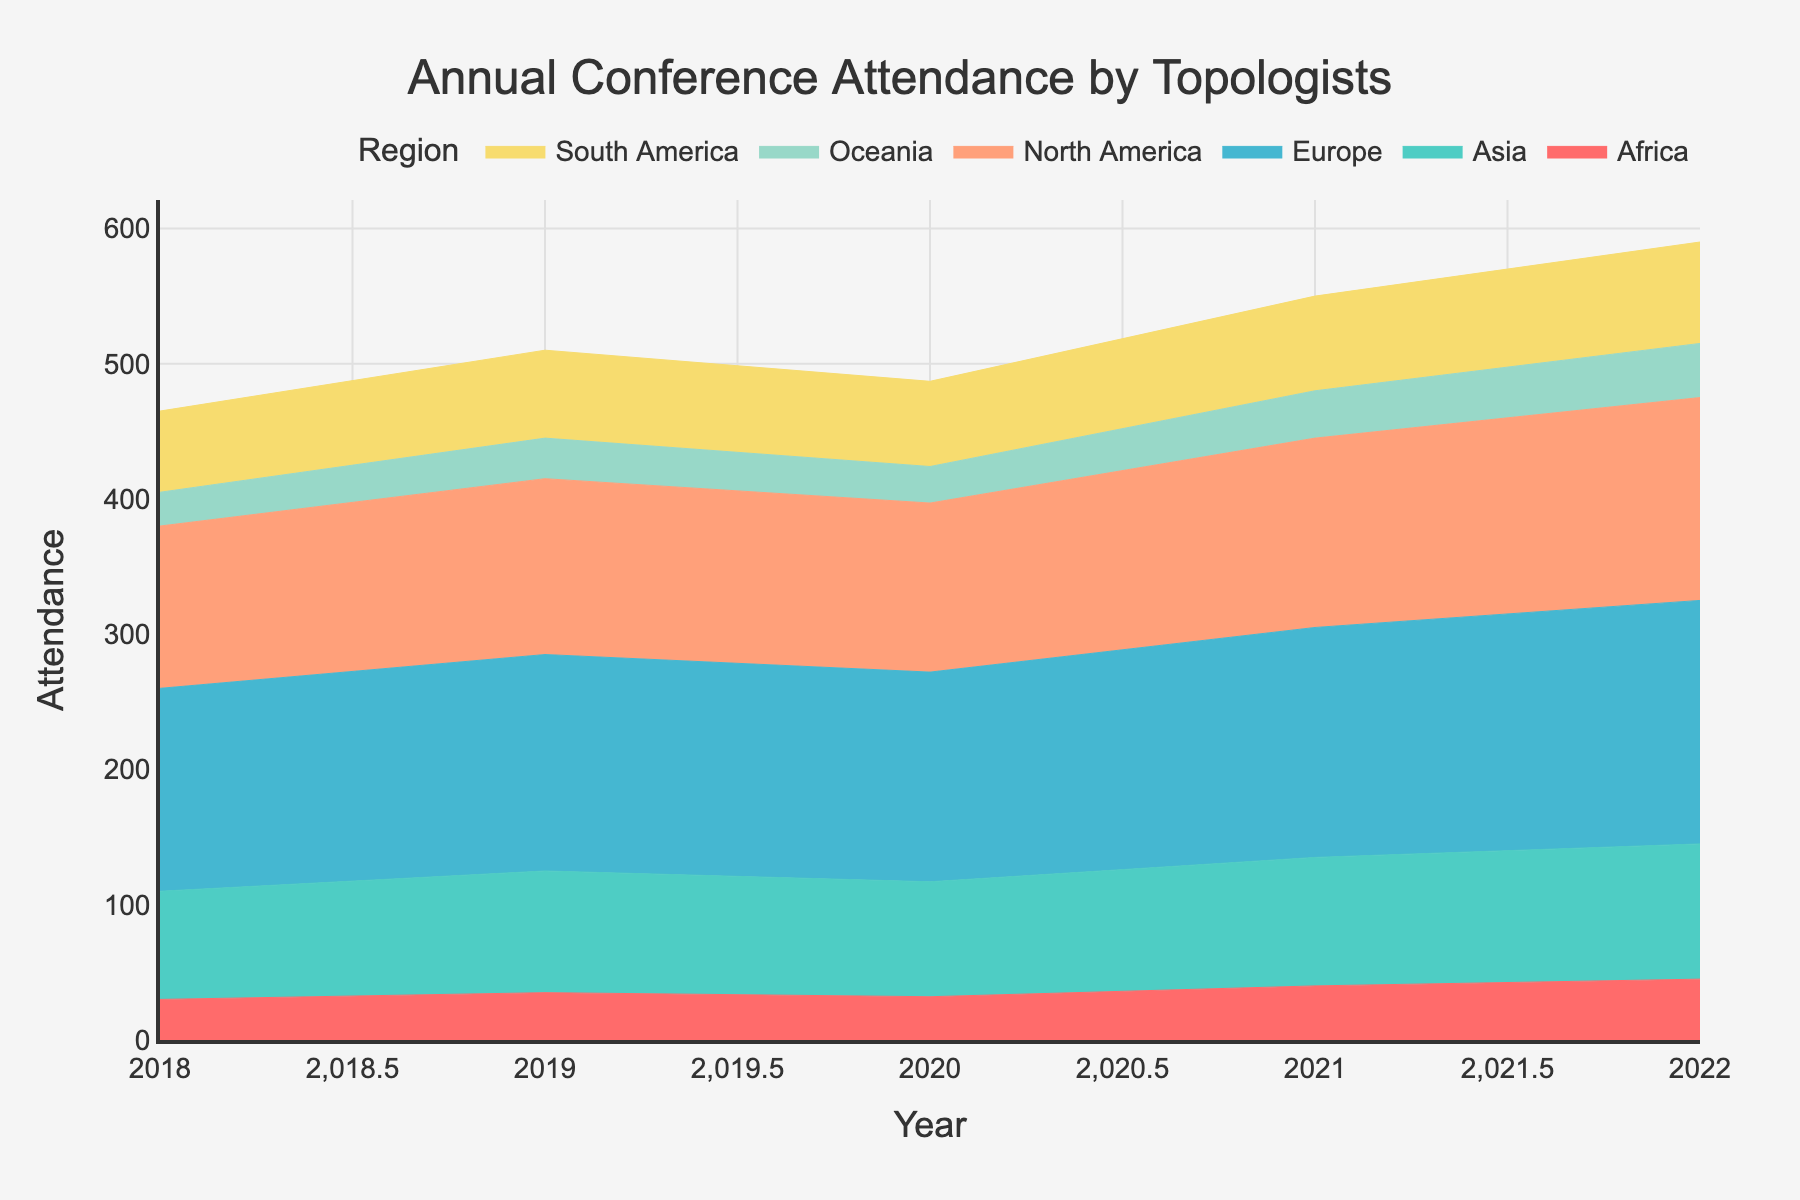What is the title of the figure? The title is often placed at the top of the figure and provides a summary of what the figure represents. Here, the title can be clearly seen.
Answer: Annual Conference Attendance by Topologists What do the x-axis and y-axis represent in the figure? The x-axis is labeled "Year" and represents the time period from 2018 to 2022. The y-axis is labeled "Attendance" and represents the number of attendees at the annual conference.
Answer: Year, Attendance Which region had the highest conference attendance in 2022? By looking at the topmost part of the vertical stack for the year 2022, we can see which region's area reaches the highest point.
Answer: Europe How did the attendance in Oceania change from 2018 to 2022? Observe the bottom-most stacked area representing Oceania over the years from 2018 to 2022 to see if the attendance values increase, decrease, or stay the same.
Answer: Increased What is the overall trend in the total attendance from 2018 to 2022? To determine the trend, look at the highest point of the stacked area for each year and observe if it generally increases, decreases, or stays relatively constant over time.
Answer: Increasing Which region has the smallest area in the stacked chart over the years? Compare the areas of each region. The smallest area will be the region that has the least accumulated attendance over the given years.
Answer: Africa Did the North American attendance ever decrease from one year to the next between 2018 and 2022? Look at the specific trend of the North American region’s area across each year. Identify any year where the height of the North American area decreases compared to the previous year.
Answer: Yes, from 2019 to 2020 What is the total attendance for Europe in 2020? Locate Europe in the stacked area for the year 2020 and read off the value or approximate it from the y-axis.
Answer: 155 By how much did the total attendance in Asia increase from 2018 to 2022? Note Asia's attendance values in 2018 and 2022, then subtract the 2018 value from the 2022 value to get the amount of increase.
Answer: 20 Compare the attendance trend in South America and Africa from 2018 to 2022. Look at both South America and Africa’s stacked areas and describe their changes over time. Are they increasing, decreasing, or constant?
Answer: Both are increasing 